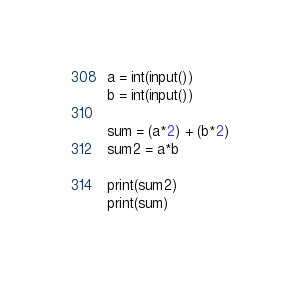<code> <loc_0><loc_0><loc_500><loc_500><_Python_>a = int(input())
b = int(input())

sum = (a*2) + (b*2)
sum2 = a*b

print(sum2)
print(sum)
</code> 